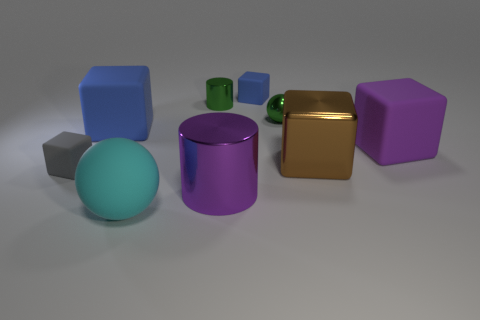Are there any other things that have the same material as the small gray cube?
Make the answer very short. Yes. There is a purple object on the left side of the ball behind the gray matte thing; what is its material?
Keep it short and to the point. Metal. How big is the blue matte block that is behind the blue rubber thing that is in front of the tiny blue matte object behind the big purple matte object?
Ensure brevity in your answer.  Small. What number of other things are there of the same shape as the cyan thing?
Provide a succinct answer. 1. Does the large object that is on the left side of the large cyan sphere have the same color as the small block in front of the large blue thing?
Ensure brevity in your answer.  No. There is a ball that is the same size as the brown cube; what color is it?
Your response must be concise. Cyan. Is there a small object of the same color as the large metallic block?
Your answer should be very brief. No. There is a ball to the left of the purple cylinder; does it have the same size as the small blue object?
Ensure brevity in your answer.  No. Are there the same number of rubber spheres that are behind the rubber ball and red balls?
Your response must be concise. Yes. How many objects are either gray cubes that are in front of the metallic sphere or blue blocks?
Ensure brevity in your answer.  3. 